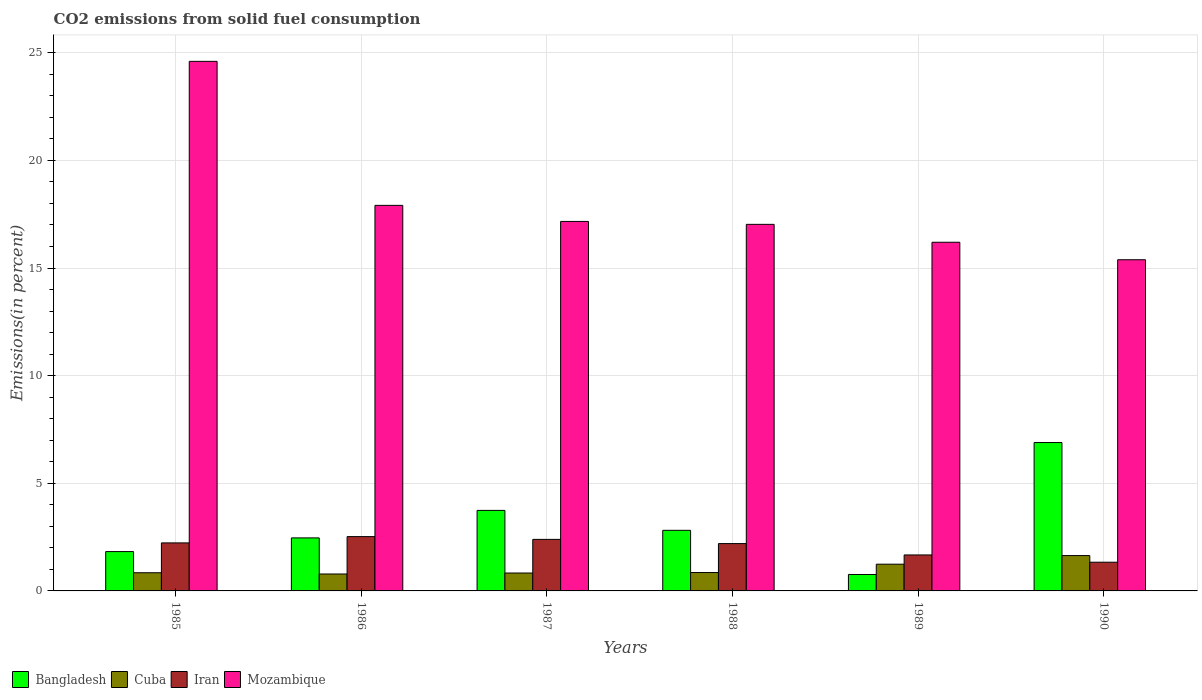How many groups of bars are there?
Make the answer very short. 6. Are the number of bars per tick equal to the number of legend labels?
Your answer should be compact. Yes. Are the number of bars on each tick of the X-axis equal?
Offer a terse response. Yes. How many bars are there on the 1st tick from the left?
Offer a terse response. 4. What is the total CO2 emitted in Bangladesh in 1985?
Your answer should be compact. 1.83. Across all years, what is the maximum total CO2 emitted in Iran?
Your answer should be compact. 2.52. Across all years, what is the minimum total CO2 emitted in Bangladesh?
Keep it short and to the point. 0.76. In which year was the total CO2 emitted in Mozambique minimum?
Your response must be concise. 1990. What is the total total CO2 emitted in Mozambique in the graph?
Make the answer very short. 108.29. What is the difference between the total CO2 emitted in Mozambique in 1985 and that in 1988?
Provide a succinct answer. 7.57. What is the difference between the total CO2 emitted in Mozambique in 1988 and the total CO2 emitted in Bangladesh in 1990?
Your answer should be very brief. 10.14. What is the average total CO2 emitted in Mozambique per year?
Give a very brief answer. 18.05. In the year 1990, what is the difference between the total CO2 emitted in Bangladesh and total CO2 emitted in Cuba?
Your answer should be very brief. 5.25. What is the ratio of the total CO2 emitted in Mozambique in 1985 to that in 1986?
Ensure brevity in your answer.  1.37. What is the difference between the highest and the second highest total CO2 emitted in Cuba?
Your response must be concise. 0.4. What is the difference between the highest and the lowest total CO2 emitted in Bangladesh?
Provide a short and direct response. 6.13. Is the sum of the total CO2 emitted in Mozambique in 1987 and 1990 greater than the maximum total CO2 emitted in Bangladesh across all years?
Offer a very short reply. Yes. Is it the case that in every year, the sum of the total CO2 emitted in Iran and total CO2 emitted in Cuba is greater than the sum of total CO2 emitted in Bangladesh and total CO2 emitted in Mozambique?
Offer a very short reply. Yes. What does the 2nd bar from the left in 1988 represents?
Offer a terse response. Cuba. What does the 4th bar from the right in 1988 represents?
Offer a very short reply. Bangladesh. Are all the bars in the graph horizontal?
Offer a terse response. No. How many years are there in the graph?
Ensure brevity in your answer.  6. What is the difference between two consecutive major ticks on the Y-axis?
Your answer should be compact. 5. Are the values on the major ticks of Y-axis written in scientific E-notation?
Offer a very short reply. No. Where does the legend appear in the graph?
Keep it short and to the point. Bottom left. How many legend labels are there?
Make the answer very short. 4. What is the title of the graph?
Your answer should be compact. CO2 emissions from solid fuel consumption. What is the label or title of the Y-axis?
Provide a succinct answer. Emissions(in percent). What is the Emissions(in percent) in Bangladesh in 1985?
Ensure brevity in your answer.  1.83. What is the Emissions(in percent) in Cuba in 1985?
Provide a short and direct response. 0.84. What is the Emissions(in percent) in Iran in 1985?
Your response must be concise. 2.23. What is the Emissions(in percent) of Mozambique in 1985?
Ensure brevity in your answer.  24.6. What is the Emissions(in percent) of Bangladesh in 1986?
Your response must be concise. 2.46. What is the Emissions(in percent) of Cuba in 1986?
Make the answer very short. 0.79. What is the Emissions(in percent) of Iran in 1986?
Make the answer very short. 2.52. What is the Emissions(in percent) in Mozambique in 1986?
Ensure brevity in your answer.  17.91. What is the Emissions(in percent) of Bangladesh in 1987?
Keep it short and to the point. 3.74. What is the Emissions(in percent) in Cuba in 1987?
Offer a terse response. 0.83. What is the Emissions(in percent) in Iran in 1987?
Offer a very short reply. 2.39. What is the Emissions(in percent) in Mozambique in 1987?
Offer a very short reply. 17.16. What is the Emissions(in percent) in Bangladesh in 1988?
Your answer should be compact. 2.82. What is the Emissions(in percent) in Cuba in 1988?
Make the answer very short. 0.85. What is the Emissions(in percent) of Iran in 1988?
Make the answer very short. 2.2. What is the Emissions(in percent) of Mozambique in 1988?
Offer a very short reply. 17.03. What is the Emissions(in percent) in Bangladesh in 1989?
Provide a short and direct response. 0.76. What is the Emissions(in percent) of Cuba in 1989?
Keep it short and to the point. 1.24. What is the Emissions(in percent) of Iran in 1989?
Provide a succinct answer. 1.67. What is the Emissions(in percent) in Mozambique in 1989?
Offer a terse response. 16.2. What is the Emissions(in percent) of Bangladesh in 1990?
Offer a very short reply. 6.89. What is the Emissions(in percent) of Cuba in 1990?
Give a very brief answer. 1.64. What is the Emissions(in percent) of Iran in 1990?
Ensure brevity in your answer.  1.33. What is the Emissions(in percent) in Mozambique in 1990?
Provide a short and direct response. 15.38. Across all years, what is the maximum Emissions(in percent) of Bangladesh?
Offer a terse response. 6.89. Across all years, what is the maximum Emissions(in percent) of Cuba?
Make the answer very short. 1.64. Across all years, what is the maximum Emissions(in percent) of Iran?
Keep it short and to the point. 2.52. Across all years, what is the maximum Emissions(in percent) in Mozambique?
Your response must be concise. 24.6. Across all years, what is the minimum Emissions(in percent) of Bangladesh?
Provide a succinct answer. 0.76. Across all years, what is the minimum Emissions(in percent) in Cuba?
Your answer should be very brief. 0.79. Across all years, what is the minimum Emissions(in percent) in Iran?
Offer a terse response. 1.33. Across all years, what is the minimum Emissions(in percent) of Mozambique?
Provide a succinct answer. 15.38. What is the total Emissions(in percent) in Bangladesh in the graph?
Provide a succinct answer. 18.5. What is the total Emissions(in percent) in Cuba in the graph?
Offer a very short reply. 6.2. What is the total Emissions(in percent) in Iran in the graph?
Offer a very short reply. 12.35. What is the total Emissions(in percent) in Mozambique in the graph?
Give a very brief answer. 108.29. What is the difference between the Emissions(in percent) of Bangladesh in 1985 and that in 1986?
Provide a succinct answer. -0.64. What is the difference between the Emissions(in percent) of Cuba in 1985 and that in 1986?
Your response must be concise. 0.06. What is the difference between the Emissions(in percent) in Iran in 1985 and that in 1986?
Offer a terse response. -0.29. What is the difference between the Emissions(in percent) in Mozambique in 1985 and that in 1986?
Provide a succinct answer. 6.69. What is the difference between the Emissions(in percent) of Bangladesh in 1985 and that in 1987?
Your answer should be very brief. -1.91. What is the difference between the Emissions(in percent) of Cuba in 1985 and that in 1987?
Offer a very short reply. 0.01. What is the difference between the Emissions(in percent) in Iran in 1985 and that in 1987?
Provide a short and direct response. -0.16. What is the difference between the Emissions(in percent) of Mozambique in 1985 and that in 1987?
Keep it short and to the point. 7.44. What is the difference between the Emissions(in percent) in Bangladesh in 1985 and that in 1988?
Give a very brief answer. -0.99. What is the difference between the Emissions(in percent) in Cuba in 1985 and that in 1988?
Keep it short and to the point. -0.01. What is the difference between the Emissions(in percent) of Iran in 1985 and that in 1988?
Provide a short and direct response. 0.03. What is the difference between the Emissions(in percent) in Mozambique in 1985 and that in 1988?
Your answer should be very brief. 7.57. What is the difference between the Emissions(in percent) in Bangladesh in 1985 and that in 1989?
Your response must be concise. 1.06. What is the difference between the Emissions(in percent) in Cuba in 1985 and that in 1989?
Provide a short and direct response. -0.4. What is the difference between the Emissions(in percent) in Iran in 1985 and that in 1989?
Offer a very short reply. 0.56. What is the difference between the Emissions(in percent) in Mozambique in 1985 and that in 1989?
Keep it short and to the point. 8.4. What is the difference between the Emissions(in percent) in Bangladesh in 1985 and that in 1990?
Keep it short and to the point. -5.07. What is the difference between the Emissions(in percent) of Cuba in 1985 and that in 1990?
Your response must be concise. -0.8. What is the difference between the Emissions(in percent) in Iran in 1985 and that in 1990?
Ensure brevity in your answer.  0.9. What is the difference between the Emissions(in percent) in Mozambique in 1985 and that in 1990?
Provide a short and direct response. 9.22. What is the difference between the Emissions(in percent) of Bangladesh in 1986 and that in 1987?
Offer a very short reply. -1.28. What is the difference between the Emissions(in percent) in Cuba in 1986 and that in 1987?
Provide a short and direct response. -0.05. What is the difference between the Emissions(in percent) of Iran in 1986 and that in 1987?
Make the answer very short. 0.13. What is the difference between the Emissions(in percent) of Mozambique in 1986 and that in 1987?
Give a very brief answer. 0.75. What is the difference between the Emissions(in percent) in Bangladesh in 1986 and that in 1988?
Provide a short and direct response. -0.35. What is the difference between the Emissions(in percent) in Cuba in 1986 and that in 1988?
Give a very brief answer. -0.07. What is the difference between the Emissions(in percent) in Iran in 1986 and that in 1988?
Your response must be concise. 0.32. What is the difference between the Emissions(in percent) in Mozambique in 1986 and that in 1988?
Give a very brief answer. 0.88. What is the difference between the Emissions(in percent) in Bangladesh in 1986 and that in 1989?
Give a very brief answer. 1.7. What is the difference between the Emissions(in percent) in Cuba in 1986 and that in 1989?
Provide a short and direct response. -0.46. What is the difference between the Emissions(in percent) of Iran in 1986 and that in 1989?
Give a very brief answer. 0.85. What is the difference between the Emissions(in percent) of Mozambique in 1986 and that in 1989?
Give a very brief answer. 1.71. What is the difference between the Emissions(in percent) of Bangladesh in 1986 and that in 1990?
Give a very brief answer. -4.43. What is the difference between the Emissions(in percent) of Cuba in 1986 and that in 1990?
Offer a very short reply. -0.86. What is the difference between the Emissions(in percent) of Iran in 1986 and that in 1990?
Provide a short and direct response. 1.19. What is the difference between the Emissions(in percent) in Mozambique in 1986 and that in 1990?
Provide a short and direct response. 2.53. What is the difference between the Emissions(in percent) in Bangladesh in 1987 and that in 1988?
Make the answer very short. 0.93. What is the difference between the Emissions(in percent) of Cuba in 1987 and that in 1988?
Ensure brevity in your answer.  -0.02. What is the difference between the Emissions(in percent) of Iran in 1987 and that in 1988?
Give a very brief answer. 0.2. What is the difference between the Emissions(in percent) of Mozambique in 1987 and that in 1988?
Your answer should be very brief. 0.14. What is the difference between the Emissions(in percent) of Bangladesh in 1987 and that in 1989?
Ensure brevity in your answer.  2.98. What is the difference between the Emissions(in percent) in Cuba in 1987 and that in 1989?
Offer a terse response. -0.41. What is the difference between the Emissions(in percent) in Iran in 1987 and that in 1989?
Make the answer very short. 0.72. What is the difference between the Emissions(in percent) in Mozambique in 1987 and that in 1989?
Make the answer very short. 0.97. What is the difference between the Emissions(in percent) in Bangladesh in 1987 and that in 1990?
Your answer should be compact. -3.15. What is the difference between the Emissions(in percent) in Cuba in 1987 and that in 1990?
Provide a short and direct response. -0.81. What is the difference between the Emissions(in percent) of Iran in 1987 and that in 1990?
Your answer should be compact. 1.06. What is the difference between the Emissions(in percent) of Mozambique in 1987 and that in 1990?
Ensure brevity in your answer.  1.78. What is the difference between the Emissions(in percent) of Bangladesh in 1988 and that in 1989?
Keep it short and to the point. 2.05. What is the difference between the Emissions(in percent) in Cuba in 1988 and that in 1989?
Give a very brief answer. -0.39. What is the difference between the Emissions(in percent) of Iran in 1988 and that in 1989?
Provide a succinct answer. 0.53. What is the difference between the Emissions(in percent) of Mozambique in 1988 and that in 1989?
Offer a very short reply. 0.83. What is the difference between the Emissions(in percent) of Bangladesh in 1988 and that in 1990?
Your answer should be very brief. -4.08. What is the difference between the Emissions(in percent) in Cuba in 1988 and that in 1990?
Your answer should be compact. -0.79. What is the difference between the Emissions(in percent) of Iran in 1988 and that in 1990?
Make the answer very short. 0.86. What is the difference between the Emissions(in percent) in Mozambique in 1988 and that in 1990?
Keep it short and to the point. 1.64. What is the difference between the Emissions(in percent) in Bangladesh in 1989 and that in 1990?
Your answer should be very brief. -6.13. What is the difference between the Emissions(in percent) of Cuba in 1989 and that in 1990?
Your answer should be compact. -0.4. What is the difference between the Emissions(in percent) of Iran in 1989 and that in 1990?
Ensure brevity in your answer.  0.34. What is the difference between the Emissions(in percent) of Mozambique in 1989 and that in 1990?
Provide a short and direct response. 0.81. What is the difference between the Emissions(in percent) of Bangladesh in 1985 and the Emissions(in percent) of Cuba in 1986?
Your answer should be compact. 1.04. What is the difference between the Emissions(in percent) in Bangladesh in 1985 and the Emissions(in percent) in Iran in 1986?
Make the answer very short. -0.7. What is the difference between the Emissions(in percent) in Bangladesh in 1985 and the Emissions(in percent) in Mozambique in 1986?
Your response must be concise. -16.08. What is the difference between the Emissions(in percent) of Cuba in 1985 and the Emissions(in percent) of Iran in 1986?
Offer a terse response. -1.68. What is the difference between the Emissions(in percent) of Cuba in 1985 and the Emissions(in percent) of Mozambique in 1986?
Offer a terse response. -17.07. What is the difference between the Emissions(in percent) of Iran in 1985 and the Emissions(in percent) of Mozambique in 1986?
Offer a terse response. -15.68. What is the difference between the Emissions(in percent) in Bangladesh in 1985 and the Emissions(in percent) in Cuba in 1987?
Make the answer very short. 1. What is the difference between the Emissions(in percent) of Bangladesh in 1985 and the Emissions(in percent) of Iran in 1987?
Make the answer very short. -0.57. What is the difference between the Emissions(in percent) of Bangladesh in 1985 and the Emissions(in percent) of Mozambique in 1987?
Provide a succinct answer. -15.34. What is the difference between the Emissions(in percent) in Cuba in 1985 and the Emissions(in percent) in Iran in 1987?
Keep it short and to the point. -1.55. What is the difference between the Emissions(in percent) in Cuba in 1985 and the Emissions(in percent) in Mozambique in 1987?
Provide a short and direct response. -16.32. What is the difference between the Emissions(in percent) in Iran in 1985 and the Emissions(in percent) in Mozambique in 1987?
Ensure brevity in your answer.  -14.93. What is the difference between the Emissions(in percent) of Bangladesh in 1985 and the Emissions(in percent) of Cuba in 1988?
Give a very brief answer. 0.97. What is the difference between the Emissions(in percent) in Bangladesh in 1985 and the Emissions(in percent) in Iran in 1988?
Provide a succinct answer. -0.37. What is the difference between the Emissions(in percent) in Bangladesh in 1985 and the Emissions(in percent) in Mozambique in 1988?
Keep it short and to the point. -15.2. What is the difference between the Emissions(in percent) of Cuba in 1985 and the Emissions(in percent) of Iran in 1988?
Give a very brief answer. -1.35. What is the difference between the Emissions(in percent) of Cuba in 1985 and the Emissions(in percent) of Mozambique in 1988?
Your response must be concise. -16.18. What is the difference between the Emissions(in percent) of Iran in 1985 and the Emissions(in percent) of Mozambique in 1988?
Provide a succinct answer. -14.8. What is the difference between the Emissions(in percent) of Bangladesh in 1985 and the Emissions(in percent) of Cuba in 1989?
Make the answer very short. 0.59. What is the difference between the Emissions(in percent) of Bangladesh in 1985 and the Emissions(in percent) of Iran in 1989?
Give a very brief answer. 0.16. What is the difference between the Emissions(in percent) in Bangladesh in 1985 and the Emissions(in percent) in Mozambique in 1989?
Ensure brevity in your answer.  -14.37. What is the difference between the Emissions(in percent) of Cuba in 1985 and the Emissions(in percent) of Iran in 1989?
Your answer should be compact. -0.83. What is the difference between the Emissions(in percent) in Cuba in 1985 and the Emissions(in percent) in Mozambique in 1989?
Your answer should be very brief. -15.35. What is the difference between the Emissions(in percent) of Iran in 1985 and the Emissions(in percent) of Mozambique in 1989?
Make the answer very short. -13.97. What is the difference between the Emissions(in percent) in Bangladesh in 1985 and the Emissions(in percent) in Cuba in 1990?
Your answer should be compact. 0.19. What is the difference between the Emissions(in percent) in Bangladesh in 1985 and the Emissions(in percent) in Iran in 1990?
Ensure brevity in your answer.  0.49. What is the difference between the Emissions(in percent) of Bangladesh in 1985 and the Emissions(in percent) of Mozambique in 1990?
Give a very brief answer. -13.56. What is the difference between the Emissions(in percent) of Cuba in 1985 and the Emissions(in percent) of Iran in 1990?
Offer a very short reply. -0.49. What is the difference between the Emissions(in percent) in Cuba in 1985 and the Emissions(in percent) in Mozambique in 1990?
Keep it short and to the point. -14.54. What is the difference between the Emissions(in percent) in Iran in 1985 and the Emissions(in percent) in Mozambique in 1990?
Give a very brief answer. -13.15. What is the difference between the Emissions(in percent) in Bangladesh in 1986 and the Emissions(in percent) in Cuba in 1987?
Offer a terse response. 1.63. What is the difference between the Emissions(in percent) in Bangladesh in 1986 and the Emissions(in percent) in Iran in 1987?
Offer a very short reply. 0.07. What is the difference between the Emissions(in percent) in Bangladesh in 1986 and the Emissions(in percent) in Mozambique in 1987?
Give a very brief answer. -14.7. What is the difference between the Emissions(in percent) of Cuba in 1986 and the Emissions(in percent) of Iran in 1987?
Provide a succinct answer. -1.61. What is the difference between the Emissions(in percent) of Cuba in 1986 and the Emissions(in percent) of Mozambique in 1987?
Your answer should be very brief. -16.38. What is the difference between the Emissions(in percent) of Iran in 1986 and the Emissions(in percent) of Mozambique in 1987?
Provide a succinct answer. -14.64. What is the difference between the Emissions(in percent) in Bangladesh in 1986 and the Emissions(in percent) in Cuba in 1988?
Keep it short and to the point. 1.61. What is the difference between the Emissions(in percent) in Bangladesh in 1986 and the Emissions(in percent) in Iran in 1988?
Provide a succinct answer. 0.26. What is the difference between the Emissions(in percent) in Bangladesh in 1986 and the Emissions(in percent) in Mozambique in 1988?
Offer a very short reply. -14.57. What is the difference between the Emissions(in percent) of Cuba in 1986 and the Emissions(in percent) of Iran in 1988?
Ensure brevity in your answer.  -1.41. What is the difference between the Emissions(in percent) in Cuba in 1986 and the Emissions(in percent) in Mozambique in 1988?
Provide a succinct answer. -16.24. What is the difference between the Emissions(in percent) of Iran in 1986 and the Emissions(in percent) of Mozambique in 1988?
Keep it short and to the point. -14.51. What is the difference between the Emissions(in percent) in Bangladesh in 1986 and the Emissions(in percent) in Cuba in 1989?
Your response must be concise. 1.22. What is the difference between the Emissions(in percent) of Bangladesh in 1986 and the Emissions(in percent) of Iran in 1989?
Offer a terse response. 0.79. What is the difference between the Emissions(in percent) of Bangladesh in 1986 and the Emissions(in percent) of Mozambique in 1989?
Your answer should be very brief. -13.73. What is the difference between the Emissions(in percent) of Cuba in 1986 and the Emissions(in percent) of Iran in 1989?
Your response must be concise. -0.88. What is the difference between the Emissions(in percent) of Cuba in 1986 and the Emissions(in percent) of Mozambique in 1989?
Offer a very short reply. -15.41. What is the difference between the Emissions(in percent) of Iran in 1986 and the Emissions(in percent) of Mozambique in 1989?
Your response must be concise. -13.67. What is the difference between the Emissions(in percent) of Bangladesh in 1986 and the Emissions(in percent) of Cuba in 1990?
Give a very brief answer. 0.82. What is the difference between the Emissions(in percent) in Bangladesh in 1986 and the Emissions(in percent) in Iran in 1990?
Make the answer very short. 1.13. What is the difference between the Emissions(in percent) in Bangladesh in 1986 and the Emissions(in percent) in Mozambique in 1990?
Your answer should be very brief. -12.92. What is the difference between the Emissions(in percent) of Cuba in 1986 and the Emissions(in percent) of Iran in 1990?
Your answer should be very brief. -0.55. What is the difference between the Emissions(in percent) in Cuba in 1986 and the Emissions(in percent) in Mozambique in 1990?
Provide a short and direct response. -14.6. What is the difference between the Emissions(in percent) in Iran in 1986 and the Emissions(in percent) in Mozambique in 1990?
Offer a terse response. -12.86. What is the difference between the Emissions(in percent) of Bangladesh in 1987 and the Emissions(in percent) of Cuba in 1988?
Provide a succinct answer. 2.89. What is the difference between the Emissions(in percent) in Bangladesh in 1987 and the Emissions(in percent) in Iran in 1988?
Your response must be concise. 1.54. What is the difference between the Emissions(in percent) of Bangladesh in 1987 and the Emissions(in percent) of Mozambique in 1988?
Offer a very short reply. -13.29. What is the difference between the Emissions(in percent) in Cuba in 1987 and the Emissions(in percent) in Iran in 1988?
Keep it short and to the point. -1.37. What is the difference between the Emissions(in percent) of Cuba in 1987 and the Emissions(in percent) of Mozambique in 1988?
Offer a terse response. -16.2. What is the difference between the Emissions(in percent) in Iran in 1987 and the Emissions(in percent) in Mozambique in 1988?
Keep it short and to the point. -14.63. What is the difference between the Emissions(in percent) of Bangladesh in 1987 and the Emissions(in percent) of Cuba in 1989?
Your answer should be very brief. 2.5. What is the difference between the Emissions(in percent) in Bangladesh in 1987 and the Emissions(in percent) in Iran in 1989?
Keep it short and to the point. 2.07. What is the difference between the Emissions(in percent) in Bangladesh in 1987 and the Emissions(in percent) in Mozambique in 1989?
Offer a very short reply. -12.46. What is the difference between the Emissions(in percent) of Cuba in 1987 and the Emissions(in percent) of Iran in 1989?
Ensure brevity in your answer.  -0.84. What is the difference between the Emissions(in percent) of Cuba in 1987 and the Emissions(in percent) of Mozambique in 1989?
Offer a very short reply. -15.37. What is the difference between the Emissions(in percent) in Iran in 1987 and the Emissions(in percent) in Mozambique in 1989?
Offer a terse response. -13.8. What is the difference between the Emissions(in percent) of Bangladesh in 1987 and the Emissions(in percent) of Cuba in 1990?
Ensure brevity in your answer.  2.1. What is the difference between the Emissions(in percent) of Bangladesh in 1987 and the Emissions(in percent) of Iran in 1990?
Your response must be concise. 2.41. What is the difference between the Emissions(in percent) in Bangladesh in 1987 and the Emissions(in percent) in Mozambique in 1990?
Offer a terse response. -11.64. What is the difference between the Emissions(in percent) in Cuba in 1987 and the Emissions(in percent) in Iran in 1990?
Give a very brief answer. -0.5. What is the difference between the Emissions(in percent) of Cuba in 1987 and the Emissions(in percent) of Mozambique in 1990?
Provide a short and direct response. -14.55. What is the difference between the Emissions(in percent) of Iran in 1987 and the Emissions(in percent) of Mozambique in 1990?
Offer a terse response. -12.99. What is the difference between the Emissions(in percent) in Bangladesh in 1988 and the Emissions(in percent) in Cuba in 1989?
Provide a succinct answer. 1.57. What is the difference between the Emissions(in percent) in Bangladesh in 1988 and the Emissions(in percent) in Iran in 1989?
Ensure brevity in your answer.  1.14. What is the difference between the Emissions(in percent) in Bangladesh in 1988 and the Emissions(in percent) in Mozambique in 1989?
Make the answer very short. -13.38. What is the difference between the Emissions(in percent) in Cuba in 1988 and the Emissions(in percent) in Iran in 1989?
Your response must be concise. -0.82. What is the difference between the Emissions(in percent) of Cuba in 1988 and the Emissions(in percent) of Mozambique in 1989?
Keep it short and to the point. -15.34. What is the difference between the Emissions(in percent) in Iran in 1988 and the Emissions(in percent) in Mozambique in 1989?
Ensure brevity in your answer.  -14. What is the difference between the Emissions(in percent) in Bangladesh in 1988 and the Emissions(in percent) in Cuba in 1990?
Give a very brief answer. 1.17. What is the difference between the Emissions(in percent) of Bangladesh in 1988 and the Emissions(in percent) of Iran in 1990?
Ensure brevity in your answer.  1.48. What is the difference between the Emissions(in percent) of Bangladesh in 1988 and the Emissions(in percent) of Mozambique in 1990?
Your answer should be very brief. -12.57. What is the difference between the Emissions(in percent) in Cuba in 1988 and the Emissions(in percent) in Iran in 1990?
Make the answer very short. -0.48. What is the difference between the Emissions(in percent) of Cuba in 1988 and the Emissions(in percent) of Mozambique in 1990?
Keep it short and to the point. -14.53. What is the difference between the Emissions(in percent) of Iran in 1988 and the Emissions(in percent) of Mozambique in 1990?
Offer a very short reply. -13.19. What is the difference between the Emissions(in percent) in Bangladesh in 1989 and the Emissions(in percent) in Cuba in 1990?
Make the answer very short. -0.88. What is the difference between the Emissions(in percent) in Bangladesh in 1989 and the Emissions(in percent) in Iran in 1990?
Keep it short and to the point. -0.57. What is the difference between the Emissions(in percent) in Bangladesh in 1989 and the Emissions(in percent) in Mozambique in 1990?
Provide a short and direct response. -14.62. What is the difference between the Emissions(in percent) of Cuba in 1989 and the Emissions(in percent) of Iran in 1990?
Your answer should be very brief. -0.09. What is the difference between the Emissions(in percent) of Cuba in 1989 and the Emissions(in percent) of Mozambique in 1990?
Ensure brevity in your answer.  -14.14. What is the difference between the Emissions(in percent) in Iran in 1989 and the Emissions(in percent) in Mozambique in 1990?
Provide a short and direct response. -13.71. What is the average Emissions(in percent) of Bangladesh per year?
Ensure brevity in your answer.  3.08. What is the average Emissions(in percent) of Cuba per year?
Offer a terse response. 1.03. What is the average Emissions(in percent) in Iran per year?
Your answer should be very brief. 2.06. What is the average Emissions(in percent) of Mozambique per year?
Your answer should be compact. 18.05. In the year 1985, what is the difference between the Emissions(in percent) of Bangladesh and Emissions(in percent) of Cuba?
Give a very brief answer. 0.98. In the year 1985, what is the difference between the Emissions(in percent) in Bangladesh and Emissions(in percent) in Iran?
Ensure brevity in your answer.  -0.4. In the year 1985, what is the difference between the Emissions(in percent) of Bangladesh and Emissions(in percent) of Mozambique?
Provide a short and direct response. -22.77. In the year 1985, what is the difference between the Emissions(in percent) in Cuba and Emissions(in percent) in Iran?
Make the answer very short. -1.39. In the year 1985, what is the difference between the Emissions(in percent) in Cuba and Emissions(in percent) in Mozambique?
Offer a terse response. -23.76. In the year 1985, what is the difference between the Emissions(in percent) in Iran and Emissions(in percent) in Mozambique?
Ensure brevity in your answer.  -22.37. In the year 1986, what is the difference between the Emissions(in percent) of Bangladesh and Emissions(in percent) of Cuba?
Make the answer very short. 1.68. In the year 1986, what is the difference between the Emissions(in percent) of Bangladesh and Emissions(in percent) of Iran?
Offer a terse response. -0.06. In the year 1986, what is the difference between the Emissions(in percent) of Bangladesh and Emissions(in percent) of Mozambique?
Provide a succinct answer. -15.45. In the year 1986, what is the difference between the Emissions(in percent) in Cuba and Emissions(in percent) in Iran?
Your answer should be compact. -1.74. In the year 1986, what is the difference between the Emissions(in percent) of Cuba and Emissions(in percent) of Mozambique?
Make the answer very short. -17.12. In the year 1986, what is the difference between the Emissions(in percent) of Iran and Emissions(in percent) of Mozambique?
Give a very brief answer. -15.39. In the year 1987, what is the difference between the Emissions(in percent) of Bangladesh and Emissions(in percent) of Cuba?
Give a very brief answer. 2.91. In the year 1987, what is the difference between the Emissions(in percent) of Bangladesh and Emissions(in percent) of Iran?
Offer a terse response. 1.35. In the year 1987, what is the difference between the Emissions(in percent) in Bangladesh and Emissions(in percent) in Mozambique?
Offer a very short reply. -13.42. In the year 1987, what is the difference between the Emissions(in percent) of Cuba and Emissions(in percent) of Iran?
Provide a succinct answer. -1.56. In the year 1987, what is the difference between the Emissions(in percent) of Cuba and Emissions(in percent) of Mozambique?
Provide a short and direct response. -16.33. In the year 1987, what is the difference between the Emissions(in percent) in Iran and Emissions(in percent) in Mozambique?
Your answer should be very brief. -14.77. In the year 1988, what is the difference between the Emissions(in percent) in Bangladesh and Emissions(in percent) in Cuba?
Ensure brevity in your answer.  1.96. In the year 1988, what is the difference between the Emissions(in percent) of Bangladesh and Emissions(in percent) of Iran?
Offer a very short reply. 0.62. In the year 1988, what is the difference between the Emissions(in percent) in Bangladesh and Emissions(in percent) in Mozambique?
Provide a short and direct response. -14.21. In the year 1988, what is the difference between the Emissions(in percent) of Cuba and Emissions(in percent) of Iran?
Make the answer very short. -1.34. In the year 1988, what is the difference between the Emissions(in percent) in Cuba and Emissions(in percent) in Mozambique?
Make the answer very short. -16.17. In the year 1988, what is the difference between the Emissions(in percent) in Iran and Emissions(in percent) in Mozambique?
Provide a short and direct response. -14.83. In the year 1989, what is the difference between the Emissions(in percent) of Bangladesh and Emissions(in percent) of Cuba?
Your response must be concise. -0.48. In the year 1989, what is the difference between the Emissions(in percent) of Bangladesh and Emissions(in percent) of Iran?
Give a very brief answer. -0.91. In the year 1989, what is the difference between the Emissions(in percent) of Bangladesh and Emissions(in percent) of Mozambique?
Give a very brief answer. -15.43. In the year 1989, what is the difference between the Emissions(in percent) of Cuba and Emissions(in percent) of Iran?
Your answer should be very brief. -0.43. In the year 1989, what is the difference between the Emissions(in percent) in Cuba and Emissions(in percent) in Mozambique?
Ensure brevity in your answer.  -14.96. In the year 1989, what is the difference between the Emissions(in percent) of Iran and Emissions(in percent) of Mozambique?
Give a very brief answer. -14.53. In the year 1990, what is the difference between the Emissions(in percent) of Bangladesh and Emissions(in percent) of Cuba?
Offer a terse response. 5.25. In the year 1990, what is the difference between the Emissions(in percent) of Bangladesh and Emissions(in percent) of Iran?
Ensure brevity in your answer.  5.56. In the year 1990, what is the difference between the Emissions(in percent) of Bangladesh and Emissions(in percent) of Mozambique?
Give a very brief answer. -8.49. In the year 1990, what is the difference between the Emissions(in percent) in Cuba and Emissions(in percent) in Iran?
Your answer should be very brief. 0.31. In the year 1990, what is the difference between the Emissions(in percent) of Cuba and Emissions(in percent) of Mozambique?
Your answer should be very brief. -13.74. In the year 1990, what is the difference between the Emissions(in percent) of Iran and Emissions(in percent) of Mozambique?
Ensure brevity in your answer.  -14.05. What is the ratio of the Emissions(in percent) of Bangladesh in 1985 to that in 1986?
Provide a short and direct response. 0.74. What is the ratio of the Emissions(in percent) of Cuba in 1985 to that in 1986?
Give a very brief answer. 1.07. What is the ratio of the Emissions(in percent) of Iran in 1985 to that in 1986?
Offer a very short reply. 0.88. What is the ratio of the Emissions(in percent) of Mozambique in 1985 to that in 1986?
Keep it short and to the point. 1.37. What is the ratio of the Emissions(in percent) in Bangladesh in 1985 to that in 1987?
Provide a short and direct response. 0.49. What is the ratio of the Emissions(in percent) in Cuba in 1985 to that in 1987?
Your answer should be compact. 1.02. What is the ratio of the Emissions(in percent) in Iran in 1985 to that in 1987?
Offer a terse response. 0.93. What is the ratio of the Emissions(in percent) in Mozambique in 1985 to that in 1987?
Make the answer very short. 1.43. What is the ratio of the Emissions(in percent) of Bangladesh in 1985 to that in 1988?
Give a very brief answer. 0.65. What is the ratio of the Emissions(in percent) in Cuba in 1985 to that in 1988?
Your response must be concise. 0.99. What is the ratio of the Emissions(in percent) in Iran in 1985 to that in 1988?
Give a very brief answer. 1.01. What is the ratio of the Emissions(in percent) of Mozambique in 1985 to that in 1988?
Ensure brevity in your answer.  1.44. What is the ratio of the Emissions(in percent) of Bangladesh in 1985 to that in 1989?
Offer a very short reply. 2.39. What is the ratio of the Emissions(in percent) of Cuba in 1985 to that in 1989?
Your response must be concise. 0.68. What is the ratio of the Emissions(in percent) of Iran in 1985 to that in 1989?
Keep it short and to the point. 1.33. What is the ratio of the Emissions(in percent) of Mozambique in 1985 to that in 1989?
Offer a terse response. 1.52. What is the ratio of the Emissions(in percent) of Bangladesh in 1985 to that in 1990?
Offer a very short reply. 0.27. What is the ratio of the Emissions(in percent) of Cuba in 1985 to that in 1990?
Give a very brief answer. 0.51. What is the ratio of the Emissions(in percent) of Iran in 1985 to that in 1990?
Keep it short and to the point. 1.67. What is the ratio of the Emissions(in percent) in Mozambique in 1985 to that in 1990?
Keep it short and to the point. 1.6. What is the ratio of the Emissions(in percent) in Bangladesh in 1986 to that in 1987?
Make the answer very short. 0.66. What is the ratio of the Emissions(in percent) in Cuba in 1986 to that in 1987?
Your answer should be compact. 0.95. What is the ratio of the Emissions(in percent) of Iran in 1986 to that in 1987?
Your response must be concise. 1.05. What is the ratio of the Emissions(in percent) in Mozambique in 1986 to that in 1987?
Offer a terse response. 1.04. What is the ratio of the Emissions(in percent) of Bangladesh in 1986 to that in 1988?
Provide a short and direct response. 0.87. What is the ratio of the Emissions(in percent) in Cuba in 1986 to that in 1988?
Ensure brevity in your answer.  0.92. What is the ratio of the Emissions(in percent) in Iran in 1986 to that in 1988?
Make the answer very short. 1.15. What is the ratio of the Emissions(in percent) of Mozambique in 1986 to that in 1988?
Offer a very short reply. 1.05. What is the ratio of the Emissions(in percent) of Bangladesh in 1986 to that in 1989?
Keep it short and to the point. 3.23. What is the ratio of the Emissions(in percent) in Cuba in 1986 to that in 1989?
Offer a terse response. 0.63. What is the ratio of the Emissions(in percent) in Iran in 1986 to that in 1989?
Ensure brevity in your answer.  1.51. What is the ratio of the Emissions(in percent) of Mozambique in 1986 to that in 1989?
Keep it short and to the point. 1.11. What is the ratio of the Emissions(in percent) in Bangladesh in 1986 to that in 1990?
Provide a succinct answer. 0.36. What is the ratio of the Emissions(in percent) of Cuba in 1986 to that in 1990?
Ensure brevity in your answer.  0.48. What is the ratio of the Emissions(in percent) of Iran in 1986 to that in 1990?
Offer a terse response. 1.89. What is the ratio of the Emissions(in percent) of Mozambique in 1986 to that in 1990?
Keep it short and to the point. 1.16. What is the ratio of the Emissions(in percent) in Bangladesh in 1987 to that in 1988?
Offer a terse response. 1.33. What is the ratio of the Emissions(in percent) of Cuba in 1987 to that in 1988?
Give a very brief answer. 0.97. What is the ratio of the Emissions(in percent) in Iran in 1987 to that in 1988?
Ensure brevity in your answer.  1.09. What is the ratio of the Emissions(in percent) of Mozambique in 1987 to that in 1988?
Offer a very short reply. 1.01. What is the ratio of the Emissions(in percent) of Bangladesh in 1987 to that in 1989?
Offer a very short reply. 4.9. What is the ratio of the Emissions(in percent) in Cuba in 1987 to that in 1989?
Make the answer very short. 0.67. What is the ratio of the Emissions(in percent) of Iran in 1987 to that in 1989?
Provide a succinct answer. 1.43. What is the ratio of the Emissions(in percent) of Mozambique in 1987 to that in 1989?
Provide a succinct answer. 1.06. What is the ratio of the Emissions(in percent) in Bangladesh in 1987 to that in 1990?
Provide a succinct answer. 0.54. What is the ratio of the Emissions(in percent) of Cuba in 1987 to that in 1990?
Your answer should be very brief. 0.51. What is the ratio of the Emissions(in percent) in Iran in 1987 to that in 1990?
Offer a terse response. 1.79. What is the ratio of the Emissions(in percent) of Mozambique in 1987 to that in 1990?
Provide a succinct answer. 1.12. What is the ratio of the Emissions(in percent) of Bangladesh in 1988 to that in 1989?
Your answer should be compact. 3.69. What is the ratio of the Emissions(in percent) in Cuba in 1988 to that in 1989?
Offer a very short reply. 0.69. What is the ratio of the Emissions(in percent) of Iran in 1988 to that in 1989?
Your answer should be compact. 1.32. What is the ratio of the Emissions(in percent) in Mozambique in 1988 to that in 1989?
Provide a succinct answer. 1.05. What is the ratio of the Emissions(in percent) in Bangladesh in 1988 to that in 1990?
Your response must be concise. 0.41. What is the ratio of the Emissions(in percent) in Cuba in 1988 to that in 1990?
Ensure brevity in your answer.  0.52. What is the ratio of the Emissions(in percent) of Iran in 1988 to that in 1990?
Give a very brief answer. 1.65. What is the ratio of the Emissions(in percent) of Mozambique in 1988 to that in 1990?
Ensure brevity in your answer.  1.11. What is the ratio of the Emissions(in percent) in Bangladesh in 1989 to that in 1990?
Keep it short and to the point. 0.11. What is the ratio of the Emissions(in percent) in Cuba in 1989 to that in 1990?
Keep it short and to the point. 0.76. What is the ratio of the Emissions(in percent) in Iran in 1989 to that in 1990?
Provide a succinct answer. 1.25. What is the ratio of the Emissions(in percent) in Mozambique in 1989 to that in 1990?
Provide a short and direct response. 1.05. What is the difference between the highest and the second highest Emissions(in percent) of Bangladesh?
Provide a succinct answer. 3.15. What is the difference between the highest and the second highest Emissions(in percent) in Cuba?
Offer a very short reply. 0.4. What is the difference between the highest and the second highest Emissions(in percent) of Iran?
Your answer should be very brief. 0.13. What is the difference between the highest and the second highest Emissions(in percent) of Mozambique?
Offer a terse response. 6.69. What is the difference between the highest and the lowest Emissions(in percent) in Bangladesh?
Your response must be concise. 6.13. What is the difference between the highest and the lowest Emissions(in percent) of Cuba?
Your answer should be compact. 0.86. What is the difference between the highest and the lowest Emissions(in percent) of Iran?
Provide a succinct answer. 1.19. What is the difference between the highest and the lowest Emissions(in percent) of Mozambique?
Give a very brief answer. 9.22. 